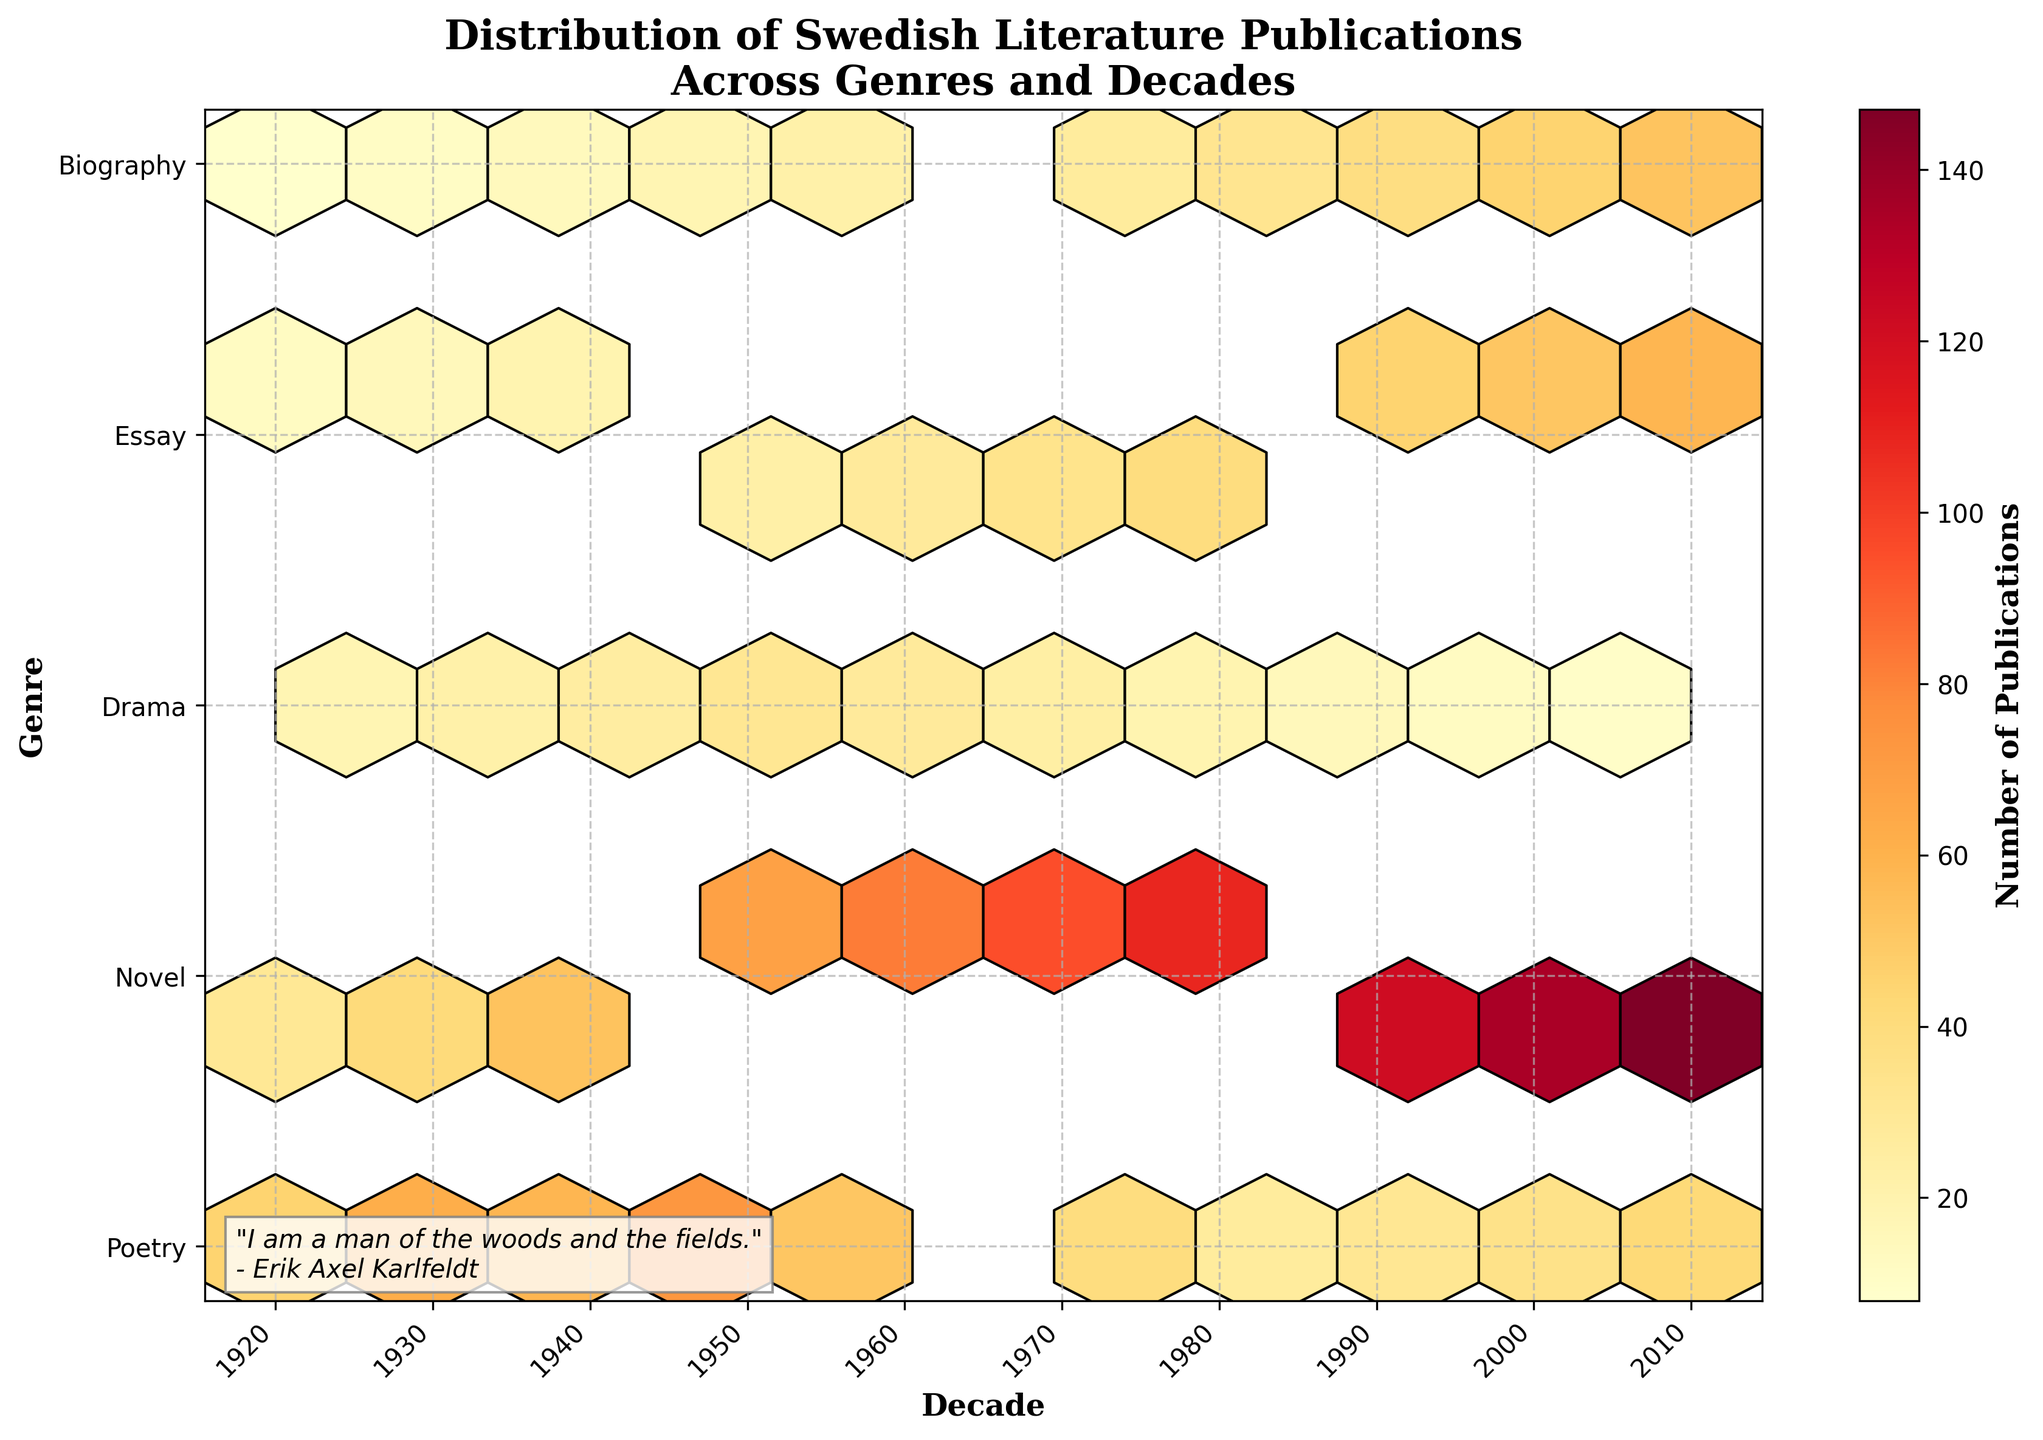What is the title of the figure? The title of the figure is usually located at the top of the plot. It should be read directly from the plot.
Answer: Distribution of Swedish Literature Publications Across Genres and Decades What does the colorbar represent? The colorbar typically represents the value associated with the color gradient in the hexbin plot. In this figure, it indicates the number of publications.
Answer: Number of Publications Between which decades does the data range? Look at the x-axis labels which represent the decades. The data range is from the earliest to the latest decade labeled.
Answer: 1920 to 2010 Which genre has the highest number of publications in the 2010s? Find the hexagon with the darkest color in the column representing the 2010s and match it with the corresponding genre on the y-axis.
Answer: Novel How did the number of Poetry publications change between the 1920s and 1930s? Compare the color intensity of hexagons representing Poetry in the 1920s and 1930s. The higher the number, the darker the color.
Answer: Increased What is the trend in Drama publications from 1920 to 2010? Observe the pattern of hexagon colors for Drama across the decades on the x-axis. Determine whether the colors get lighter or darker over time, indicating a decrease or increase in numbers.
Answer: Decreasing Which genre saw the most consistent growth in publications over the decades? Compare the trend lines (color patterns) across all genres. Consistent growth will show a steady darkening of hexagons over time.
Answer: Novel In which decade did Essays see the highest number of publications? Identify the darkest hexagon in the row corresponding to Essays and note the decade on the x-axis.
Answer: 2010s Which two genres had the closest number of publications in the 1950s? Compare the color intensity of hexagons in the 1950s column across all genres. The closest numbers will have very similar color shades.
Answer: Poetry and Drama Did the number of publications for Biographies increase or decrease by 1980 compared to 1940? Compare the color shades of hexagons for Biographies in 1940 and 1980. Darker hexagons indicate a higher number of publications.
Answer: Increase 